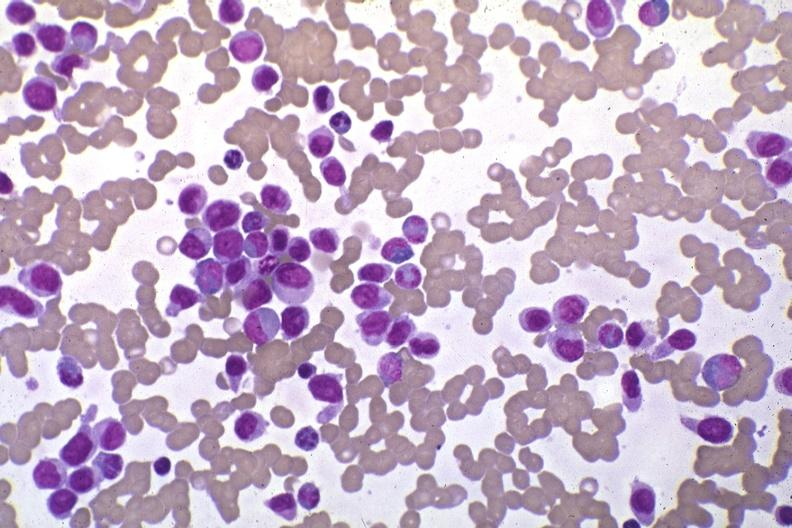does atrophy show wrights stain pleomorphic leukemic cells in peripheral blood prior to therapy?
Answer the question using a single word or phrase. No 